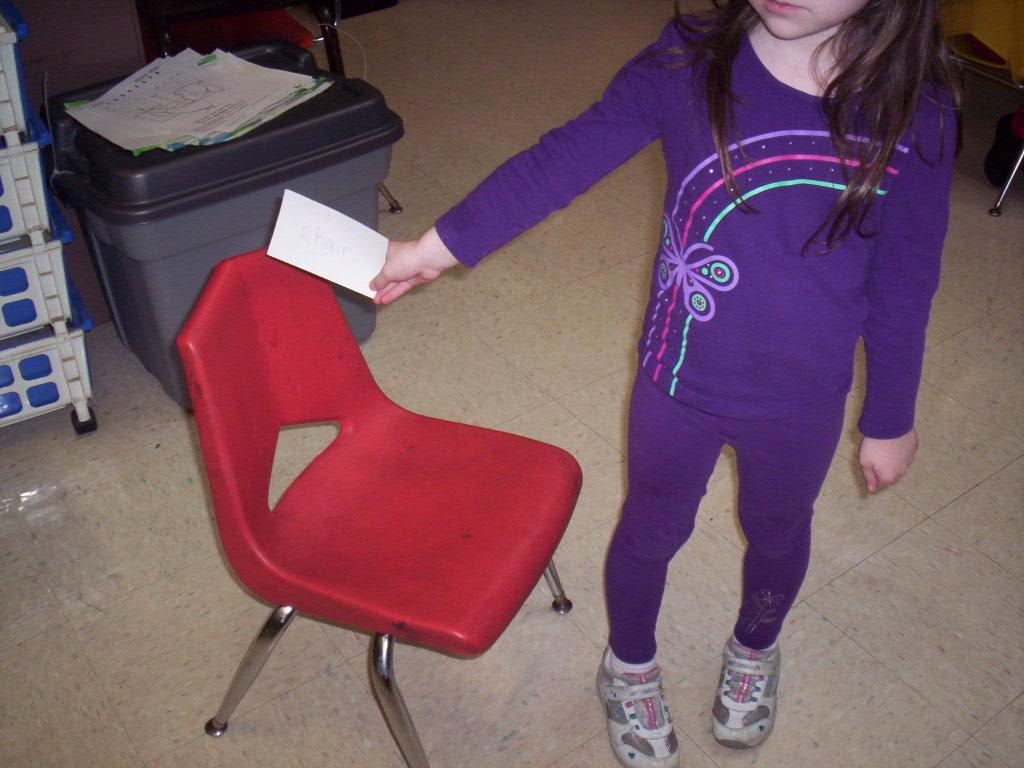Who is the main subject in the image? There is a girl in the image. What is the girl doing in the image? The girl is standing in the image. What object is present in the image besides the girl? There is a chair in the image. Where is the girl positioned in relation to the chair? The girl is beside the chair in the image. What type of toys can be seen on the floor near the girl? There are no toys visible in the image; only the girl and the chair are present. Can you tell me how many ants are crawling on the girl's shoes in the image? There are no ants present in the image; the girl is standing beside the chair without any visible insects. 